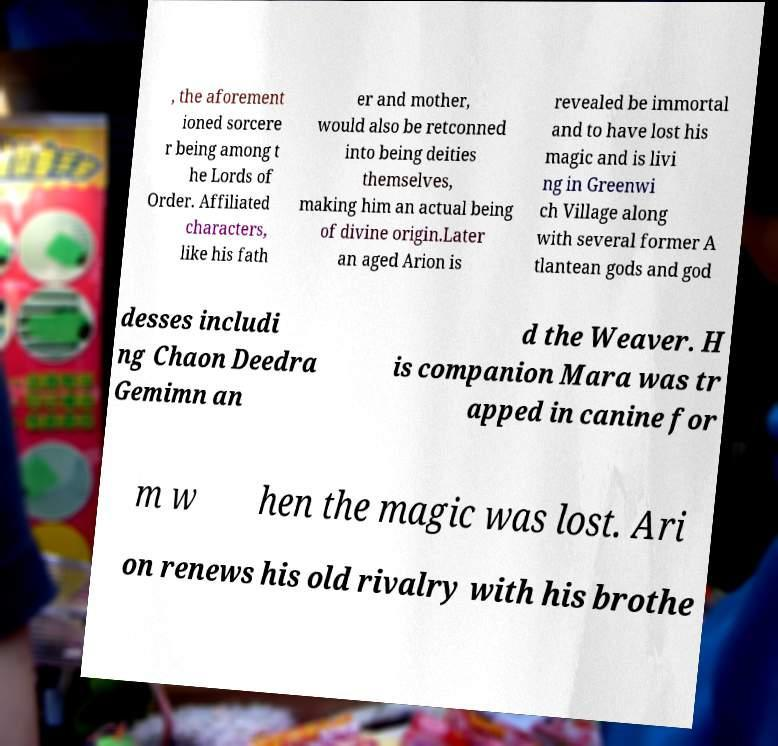Can you read and provide the text displayed in the image?This photo seems to have some interesting text. Can you extract and type it out for me? , the aforement ioned sorcere r being among t he Lords of Order. Affiliated characters, like his fath er and mother, would also be retconned into being deities themselves, making him an actual being of divine origin.Later an aged Arion is revealed be immortal and to have lost his magic and is livi ng in Greenwi ch Village along with several former A tlantean gods and god desses includi ng Chaon Deedra Gemimn an d the Weaver. H is companion Mara was tr apped in canine for m w hen the magic was lost. Ari on renews his old rivalry with his brothe 